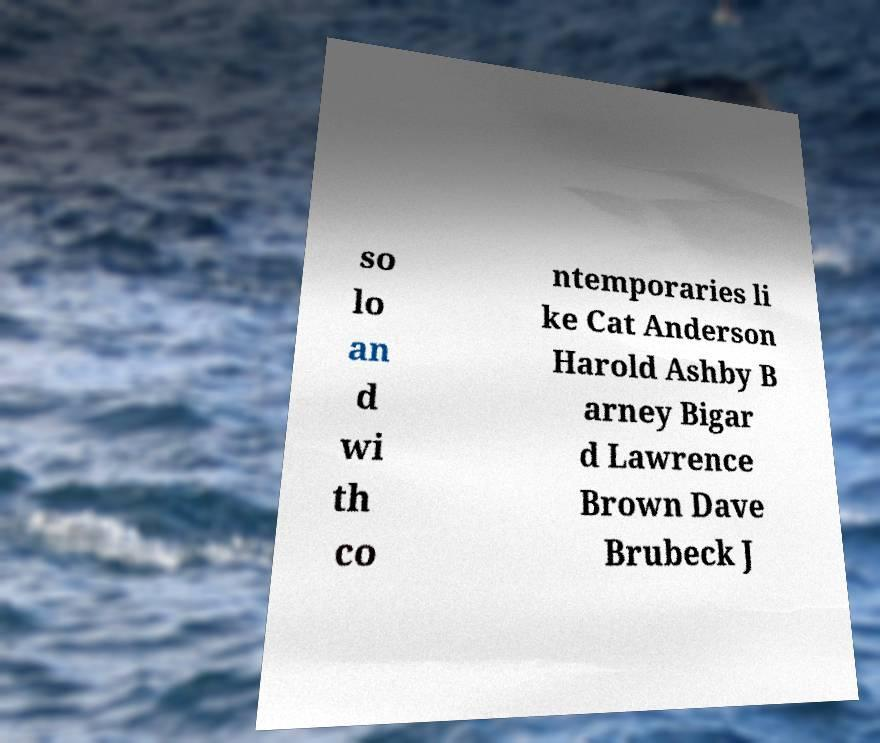Please identify and transcribe the text found in this image. so lo an d wi th co ntemporaries li ke Cat Anderson Harold Ashby B arney Bigar d Lawrence Brown Dave Brubeck J 